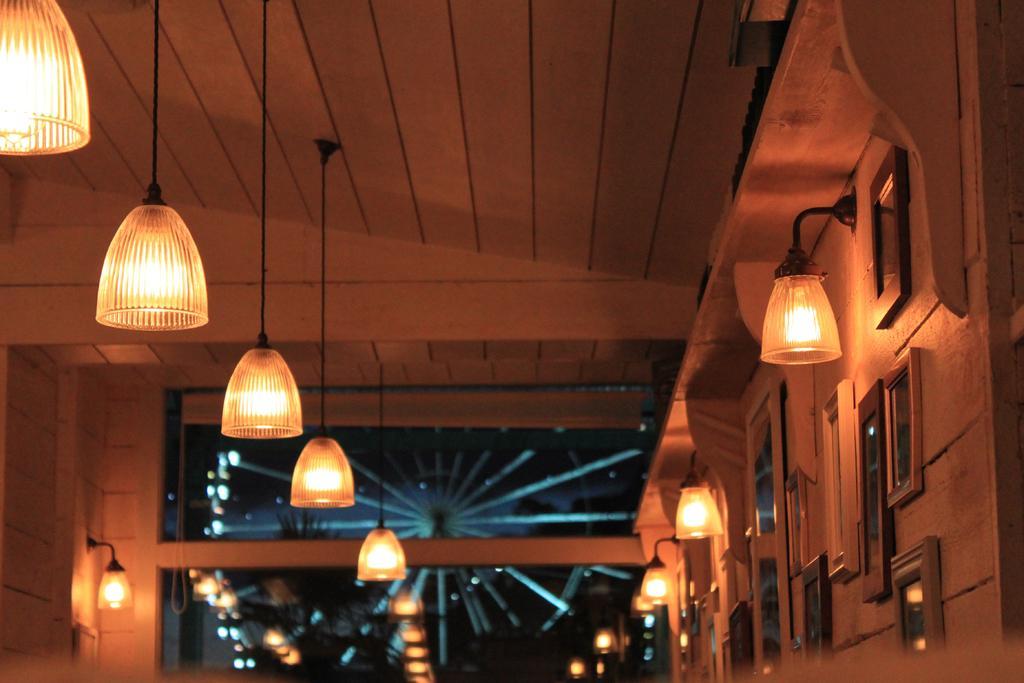Can you describe this image briefly? In this picture we can see frames on the wall, lights and in the background we can see a joint wheel. 